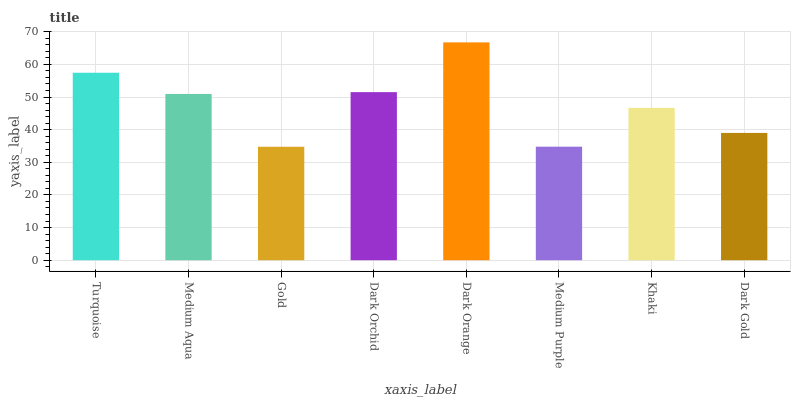Is Gold the minimum?
Answer yes or no. Yes. Is Dark Orange the maximum?
Answer yes or no. Yes. Is Medium Aqua the minimum?
Answer yes or no. No. Is Medium Aqua the maximum?
Answer yes or no. No. Is Turquoise greater than Medium Aqua?
Answer yes or no. Yes. Is Medium Aqua less than Turquoise?
Answer yes or no. Yes. Is Medium Aqua greater than Turquoise?
Answer yes or no. No. Is Turquoise less than Medium Aqua?
Answer yes or no. No. Is Medium Aqua the high median?
Answer yes or no. Yes. Is Khaki the low median?
Answer yes or no. Yes. Is Khaki the high median?
Answer yes or no. No. Is Medium Purple the low median?
Answer yes or no. No. 